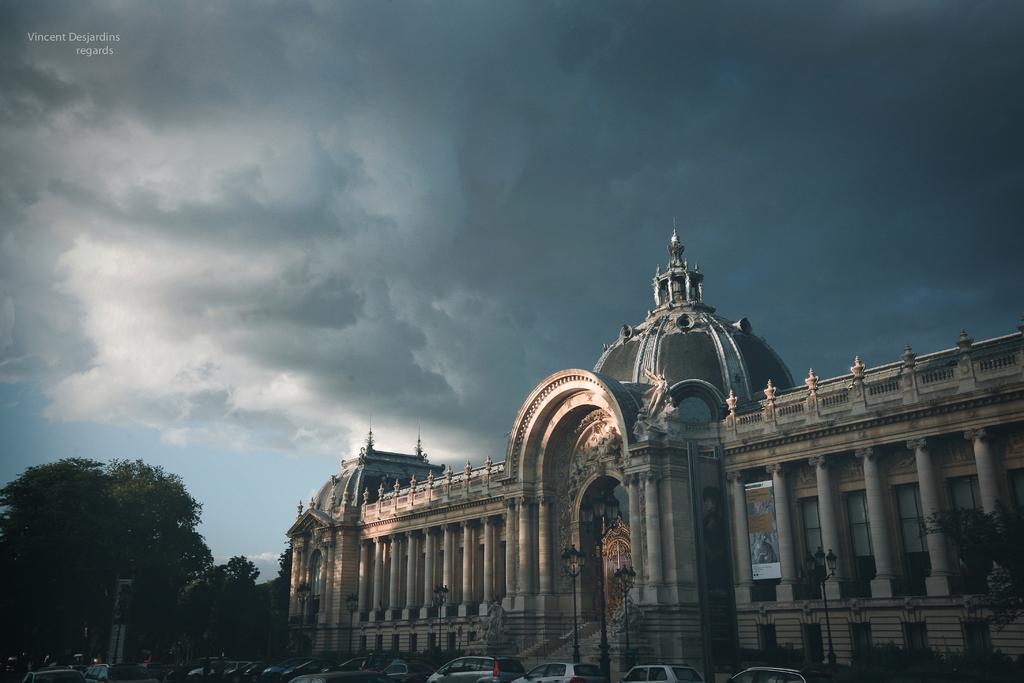Please provide a concise description of this image. This image is taken outdoors. At the top of the image there is a sky with clouds. On the left side of the image there are a few trees. At the bottom of the image many cars are parked on the ground. On the right side of the image there is a mansion with walls, windows, a door, pillars, roofs, carvings and sculptures. 